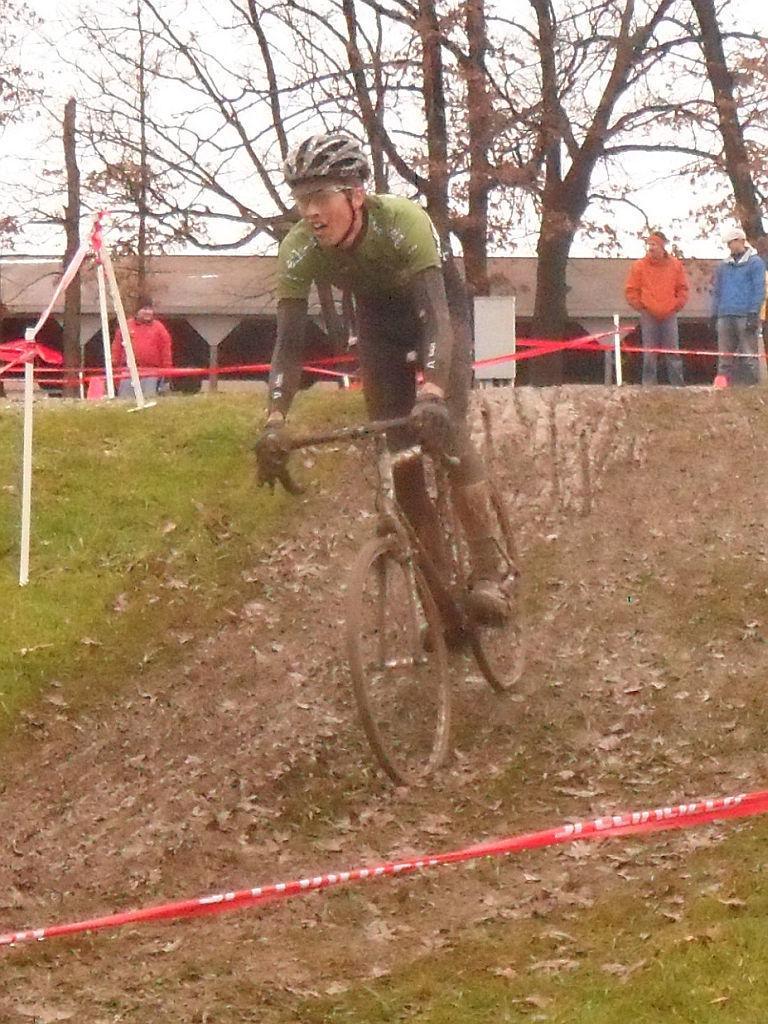In one or two sentences, can you explain what this image depicts? A man is riding bicycle. In the background there are 3 people,trees,building and sky. 